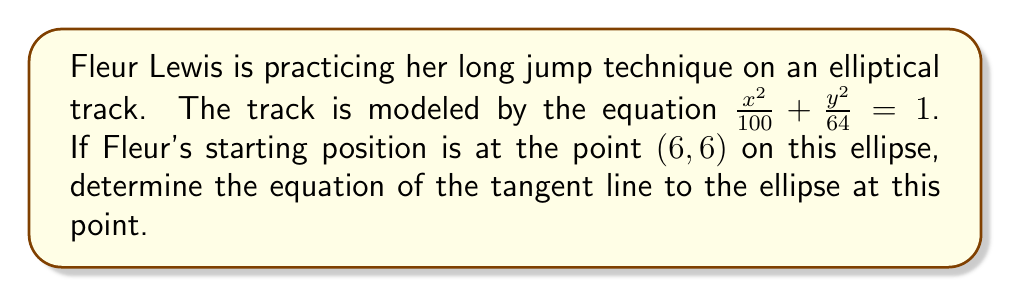Can you solve this math problem? Let's approach this step-by-step:

1) The general equation of an ellipse is $\frac{x^2}{a^2} + \frac{y^2}{b^2} = 1$. In this case, $a^2 = 100$ and $b^2 = 64$.

2) The formula for the slope of the tangent line at point $(x_0, y_0)$ on the ellipse is:

   $$m = -\frac{b^2x_0}{a^2y_0}$$

3) Substituting our values:
   $$m = -\frac{64 \cdot 6}{100 \cdot 6} = -\frac{64}{100} = -\frac{16}{25}$$

4) Now that we have the slope, we can use the point-slope form of a line:
   $y - y_0 = m(x - x_0)$

5) Substituting our point $(6, 6)$ and the slope we calculated:
   $$y - 6 = -\frac{16}{25}(x - 6)$$

6) Simplify by distributing the negative:
   $$y - 6 = -\frac{16x}{25} + \frac{96}{25}$$

7) Add 6 to both sides:
   $$y = -\frac{16x}{25} + \frac{96}{25} + 6$$

8) Simplify:
   $$y = -\frac{16x}{25} + \frac{246}{25}$$

9) Multiply both sides by 25:
   $$25y = -16x + 246$$

10) Rearrange to standard form:
    $$16x + 25y = 246$$
Answer: $16x + 25y = 246$ 